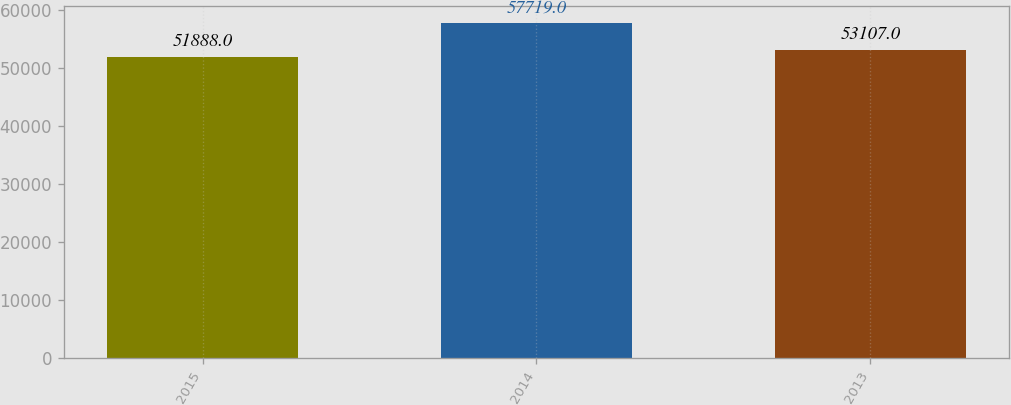<chart> <loc_0><loc_0><loc_500><loc_500><bar_chart><fcel>2015<fcel>2014<fcel>2013<nl><fcel>51888<fcel>57719<fcel>53107<nl></chart> 